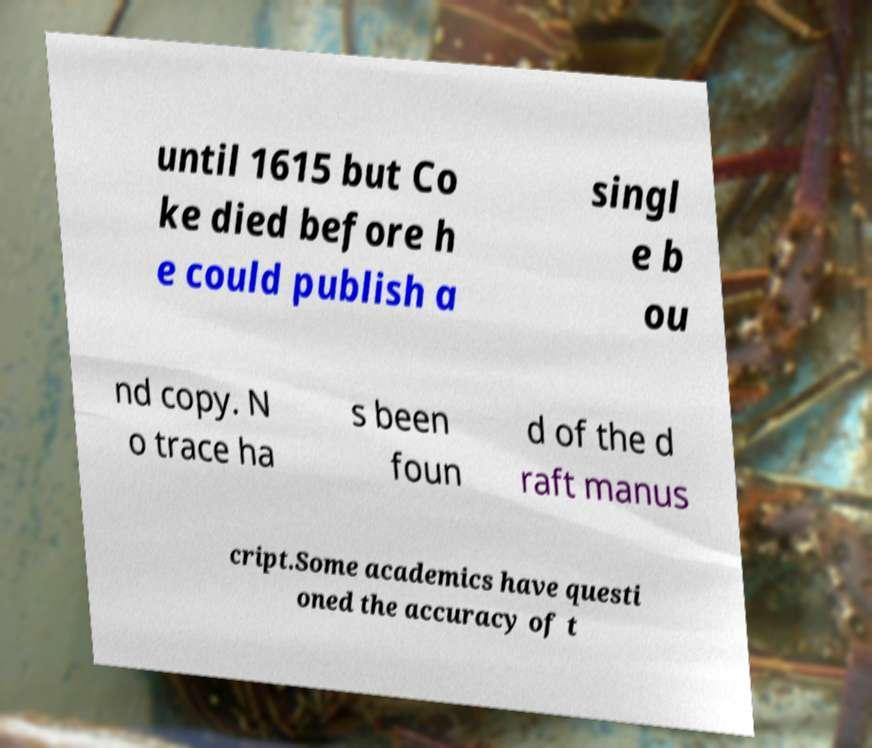Please identify and transcribe the text found in this image. until 1615 but Co ke died before h e could publish a singl e b ou nd copy. N o trace ha s been foun d of the d raft manus cript.Some academics have questi oned the accuracy of t 